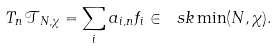<formula> <loc_0><loc_0><loc_500><loc_500>T _ { n } \mathcal { T } _ { N , \chi } = \sum _ { i } a _ { i , n } f _ { i } \in \ s k \min ( N , \chi ) .</formula> 